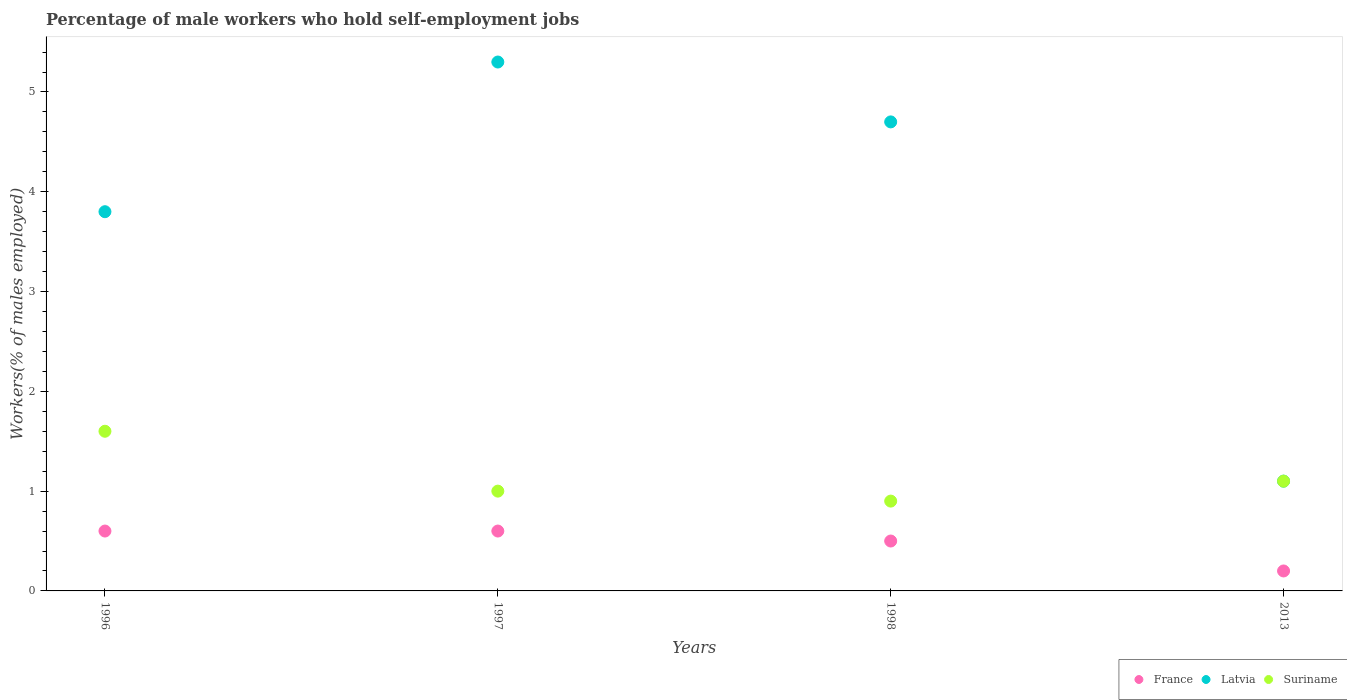How many different coloured dotlines are there?
Your response must be concise. 3. What is the percentage of self-employed male workers in Latvia in 1997?
Make the answer very short. 5.3. Across all years, what is the maximum percentage of self-employed male workers in Latvia?
Your answer should be very brief. 5.3. Across all years, what is the minimum percentage of self-employed male workers in Suriname?
Provide a short and direct response. 0.9. What is the total percentage of self-employed male workers in Suriname in the graph?
Your response must be concise. 4.6. What is the difference between the percentage of self-employed male workers in Latvia in 1997 and that in 2013?
Keep it short and to the point. 4.2. What is the difference between the percentage of self-employed male workers in Suriname in 1998 and the percentage of self-employed male workers in Latvia in 2013?
Offer a terse response. -0.2. What is the average percentage of self-employed male workers in France per year?
Your response must be concise. 0.48. In the year 2013, what is the difference between the percentage of self-employed male workers in France and percentage of self-employed male workers in Suriname?
Provide a short and direct response. -0.9. What is the ratio of the percentage of self-employed male workers in Latvia in 1997 to that in 1998?
Ensure brevity in your answer.  1.13. Is the percentage of self-employed male workers in France in 1997 less than that in 1998?
Make the answer very short. No. What is the difference between the highest and the second highest percentage of self-employed male workers in Latvia?
Ensure brevity in your answer.  0.6. What is the difference between the highest and the lowest percentage of self-employed male workers in Latvia?
Your answer should be very brief. 4.2. In how many years, is the percentage of self-employed male workers in France greater than the average percentage of self-employed male workers in France taken over all years?
Make the answer very short. 3. Is the percentage of self-employed male workers in Suriname strictly greater than the percentage of self-employed male workers in France over the years?
Provide a short and direct response. Yes. Is the percentage of self-employed male workers in Latvia strictly less than the percentage of self-employed male workers in France over the years?
Provide a short and direct response. No. What is the difference between two consecutive major ticks on the Y-axis?
Offer a very short reply. 1. Does the graph contain grids?
Your response must be concise. No. Where does the legend appear in the graph?
Offer a terse response. Bottom right. What is the title of the graph?
Give a very brief answer. Percentage of male workers who hold self-employment jobs. What is the label or title of the Y-axis?
Give a very brief answer. Workers(% of males employed). What is the Workers(% of males employed) of France in 1996?
Offer a terse response. 0.6. What is the Workers(% of males employed) of Latvia in 1996?
Keep it short and to the point. 3.8. What is the Workers(% of males employed) of Suriname in 1996?
Keep it short and to the point. 1.6. What is the Workers(% of males employed) of France in 1997?
Keep it short and to the point. 0.6. What is the Workers(% of males employed) in Latvia in 1997?
Offer a terse response. 5.3. What is the Workers(% of males employed) of France in 1998?
Offer a very short reply. 0.5. What is the Workers(% of males employed) in Latvia in 1998?
Keep it short and to the point. 4.7. What is the Workers(% of males employed) of Suriname in 1998?
Your response must be concise. 0.9. What is the Workers(% of males employed) in France in 2013?
Provide a short and direct response. 0.2. What is the Workers(% of males employed) of Latvia in 2013?
Make the answer very short. 1.1. What is the Workers(% of males employed) of Suriname in 2013?
Ensure brevity in your answer.  1.1. Across all years, what is the maximum Workers(% of males employed) in France?
Provide a short and direct response. 0.6. Across all years, what is the maximum Workers(% of males employed) of Latvia?
Ensure brevity in your answer.  5.3. Across all years, what is the maximum Workers(% of males employed) of Suriname?
Ensure brevity in your answer.  1.6. Across all years, what is the minimum Workers(% of males employed) in France?
Ensure brevity in your answer.  0.2. Across all years, what is the minimum Workers(% of males employed) of Latvia?
Provide a succinct answer. 1.1. Across all years, what is the minimum Workers(% of males employed) in Suriname?
Keep it short and to the point. 0.9. What is the total Workers(% of males employed) in Latvia in the graph?
Your answer should be very brief. 14.9. What is the difference between the Workers(% of males employed) of Suriname in 1996 and that in 1997?
Ensure brevity in your answer.  0.6. What is the difference between the Workers(% of males employed) of France in 1996 and that in 1998?
Keep it short and to the point. 0.1. What is the difference between the Workers(% of males employed) of Latvia in 1996 and that in 1998?
Your response must be concise. -0.9. What is the difference between the Workers(% of males employed) of Suriname in 1996 and that in 1998?
Your answer should be very brief. 0.7. What is the difference between the Workers(% of males employed) of France in 1996 and that in 2013?
Make the answer very short. 0.4. What is the difference between the Workers(% of males employed) in Suriname in 1996 and that in 2013?
Offer a very short reply. 0.5. What is the difference between the Workers(% of males employed) in France in 1997 and that in 1998?
Provide a succinct answer. 0.1. What is the difference between the Workers(% of males employed) in France in 1997 and that in 2013?
Make the answer very short. 0.4. What is the difference between the Workers(% of males employed) in Suriname in 1997 and that in 2013?
Make the answer very short. -0.1. What is the difference between the Workers(% of males employed) in France in 1996 and the Workers(% of males employed) in Latvia in 1997?
Your response must be concise. -4.7. What is the difference between the Workers(% of males employed) of Latvia in 1996 and the Workers(% of males employed) of Suriname in 1997?
Provide a short and direct response. 2.8. What is the difference between the Workers(% of males employed) in France in 1996 and the Workers(% of males employed) in Suriname in 1998?
Provide a succinct answer. -0.3. What is the difference between the Workers(% of males employed) of France in 1996 and the Workers(% of males employed) of Suriname in 2013?
Provide a succinct answer. -0.5. What is the difference between the Workers(% of males employed) in Latvia in 1996 and the Workers(% of males employed) in Suriname in 2013?
Make the answer very short. 2.7. What is the difference between the Workers(% of males employed) in France in 1997 and the Workers(% of males employed) in Latvia in 1998?
Your response must be concise. -4.1. What is the difference between the Workers(% of males employed) in Latvia in 1997 and the Workers(% of males employed) in Suriname in 1998?
Provide a succinct answer. 4.4. What is the difference between the Workers(% of males employed) of France in 1997 and the Workers(% of males employed) of Suriname in 2013?
Make the answer very short. -0.5. What is the difference between the Workers(% of males employed) of France in 1998 and the Workers(% of males employed) of Suriname in 2013?
Ensure brevity in your answer.  -0.6. What is the difference between the Workers(% of males employed) of Latvia in 1998 and the Workers(% of males employed) of Suriname in 2013?
Make the answer very short. 3.6. What is the average Workers(% of males employed) of France per year?
Give a very brief answer. 0.47. What is the average Workers(% of males employed) of Latvia per year?
Give a very brief answer. 3.73. What is the average Workers(% of males employed) of Suriname per year?
Offer a terse response. 1.15. In the year 1996, what is the difference between the Workers(% of males employed) of Latvia and Workers(% of males employed) of Suriname?
Give a very brief answer. 2.2. In the year 1997, what is the difference between the Workers(% of males employed) in France and Workers(% of males employed) in Latvia?
Offer a terse response. -4.7. In the year 1997, what is the difference between the Workers(% of males employed) in France and Workers(% of males employed) in Suriname?
Your answer should be compact. -0.4. In the year 1998, what is the difference between the Workers(% of males employed) in France and Workers(% of males employed) in Latvia?
Offer a very short reply. -4.2. In the year 1998, what is the difference between the Workers(% of males employed) in France and Workers(% of males employed) in Suriname?
Offer a terse response. -0.4. What is the ratio of the Workers(% of males employed) in Latvia in 1996 to that in 1997?
Ensure brevity in your answer.  0.72. What is the ratio of the Workers(% of males employed) in Suriname in 1996 to that in 1997?
Keep it short and to the point. 1.6. What is the ratio of the Workers(% of males employed) in Latvia in 1996 to that in 1998?
Offer a terse response. 0.81. What is the ratio of the Workers(% of males employed) of Suriname in 1996 to that in 1998?
Keep it short and to the point. 1.78. What is the ratio of the Workers(% of males employed) in France in 1996 to that in 2013?
Your answer should be compact. 3. What is the ratio of the Workers(% of males employed) in Latvia in 1996 to that in 2013?
Ensure brevity in your answer.  3.45. What is the ratio of the Workers(% of males employed) of Suriname in 1996 to that in 2013?
Give a very brief answer. 1.45. What is the ratio of the Workers(% of males employed) of Latvia in 1997 to that in 1998?
Provide a short and direct response. 1.13. What is the ratio of the Workers(% of males employed) in Latvia in 1997 to that in 2013?
Your response must be concise. 4.82. What is the ratio of the Workers(% of males employed) of Latvia in 1998 to that in 2013?
Provide a succinct answer. 4.27. What is the ratio of the Workers(% of males employed) in Suriname in 1998 to that in 2013?
Offer a terse response. 0.82. What is the difference between the highest and the second highest Workers(% of males employed) in Latvia?
Ensure brevity in your answer.  0.6. What is the difference between the highest and the lowest Workers(% of males employed) in France?
Offer a very short reply. 0.4. 